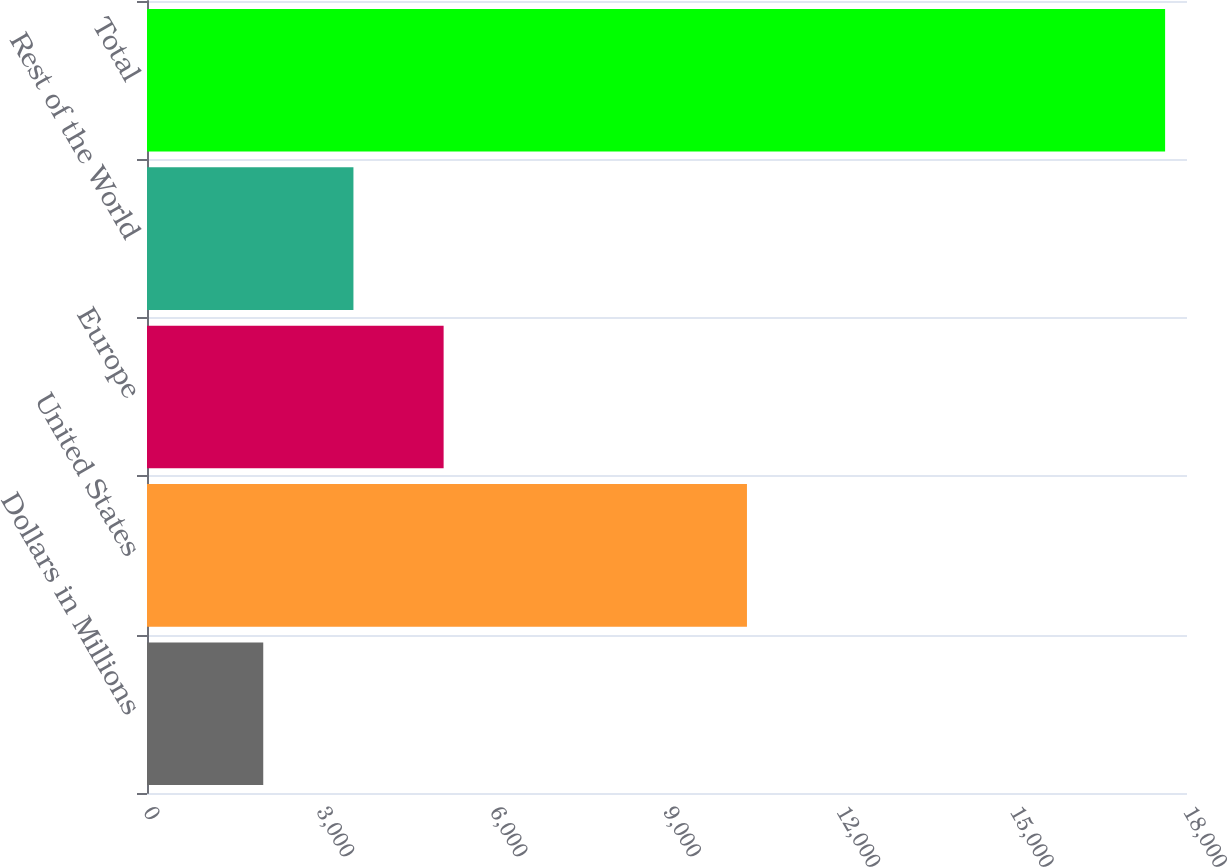<chart> <loc_0><loc_0><loc_500><loc_500><bar_chart><fcel>Dollars in Millions<fcel>United States<fcel>Europe<fcel>Rest of the World<fcel>Total<nl><fcel>2012<fcel>10384<fcel>5133.8<fcel>3572.9<fcel>17621<nl></chart> 